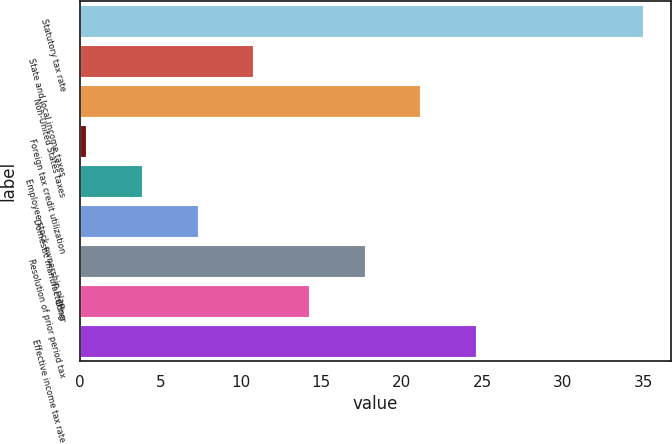Convert chart. <chart><loc_0><loc_0><loc_500><loc_500><bar_chart><fcel>Statutory tax rate<fcel>State and local income taxes<fcel>Non-United States taxes<fcel>Foreign tax credit utilization<fcel>Employee stock ownership plan<fcel>Domestic manufacturing<fcel>Resolution of prior period tax<fcel>Other<fcel>Effective income tax rate<nl><fcel>35<fcel>10.78<fcel>21.16<fcel>0.4<fcel>3.86<fcel>7.32<fcel>17.7<fcel>14.24<fcel>24.62<nl></chart> 